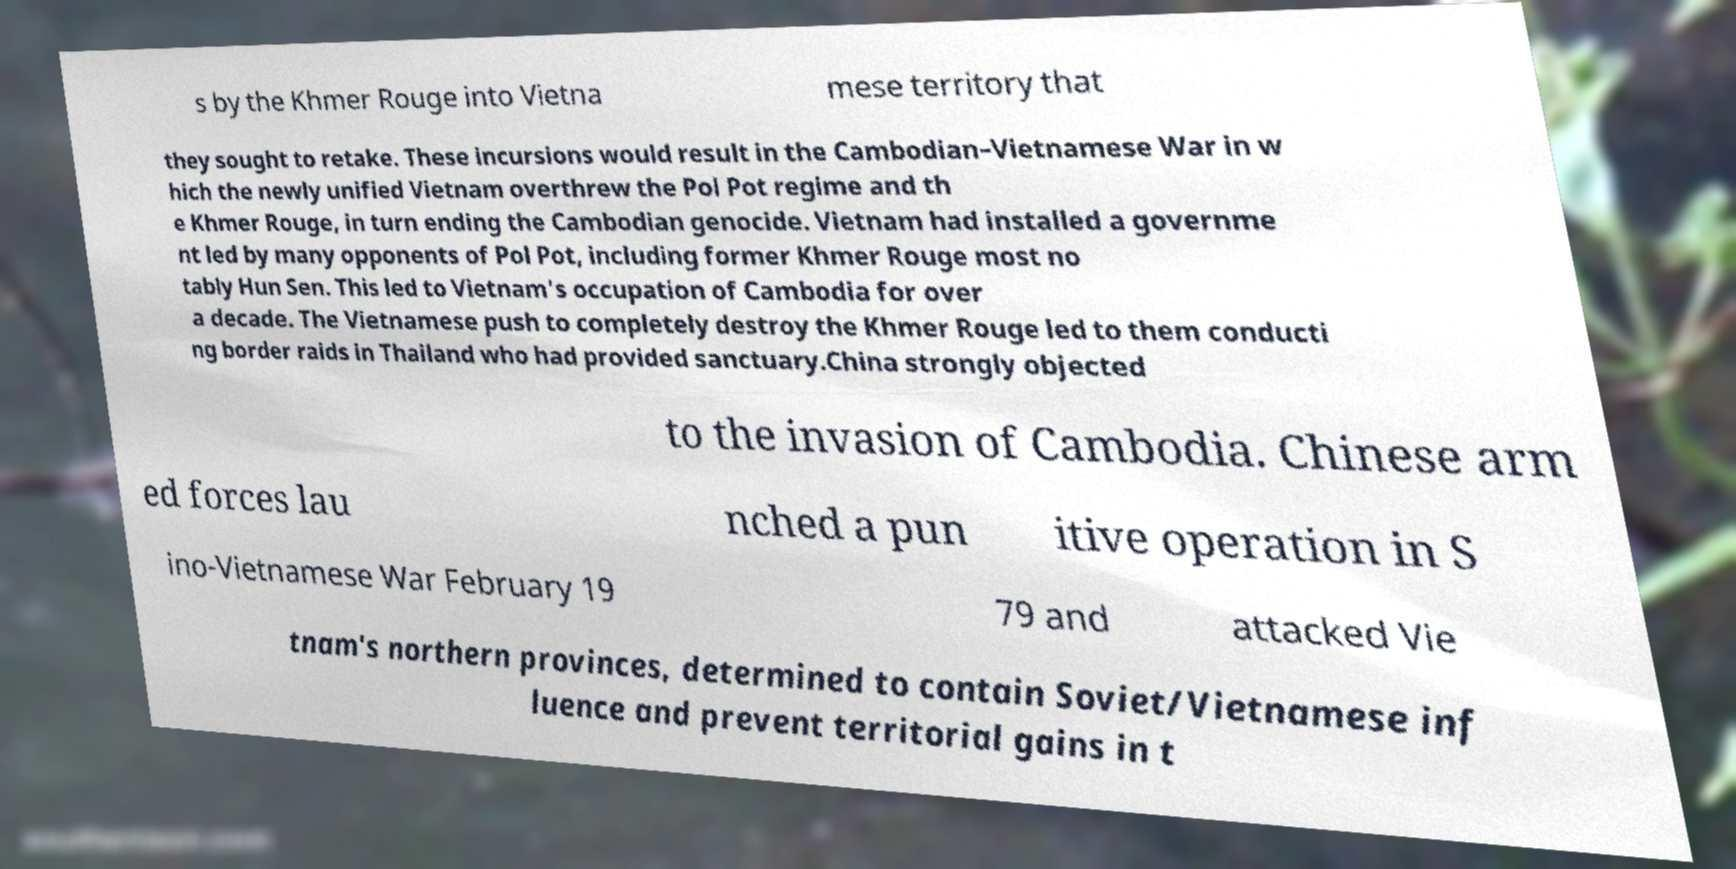Could you extract and type out the text from this image? s by the Khmer Rouge into Vietna mese territory that they sought to retake. These incursions would result in the Cambodian–Vietnamese War in w hich the newly unified Vietnam overthrew the Pol Pot regime and th e Khmer Rouge, in turn ending the Cambodian genocide. Vietnam had installed a governme nt led by many opponents of Pol Pot, including former Khmer Rouge most no tably Hun Sen. This led to Vietnam's occupation of Cambodia for over a decade. The Vietnamese push to completely destroy the Khmer Rouge led to them conducti ng border raids in Thailand who had provided sanctuary.China strongly objected to the invasion of Cambodia. Chinese arm ed forces lau nched a pun itive operation in S ino-Vietnamese War February 19 79 and attacked Vie tnam's northern provinces, determined to contain Soviet/Vietnamese inf luence and prevent territorial gains in t 